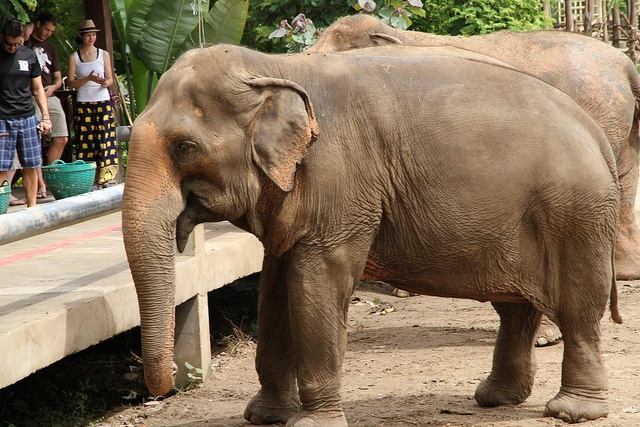Describe the objects in this image and their specific colors. I can see elephant in black, gray, tan, and maroon tones, elephant in black, tan, and gray tones, people in black and gray tones, people in black, maroon, darkgray, and gray tones, and people in black, gray, darkgray, and maroon tones in this image. 